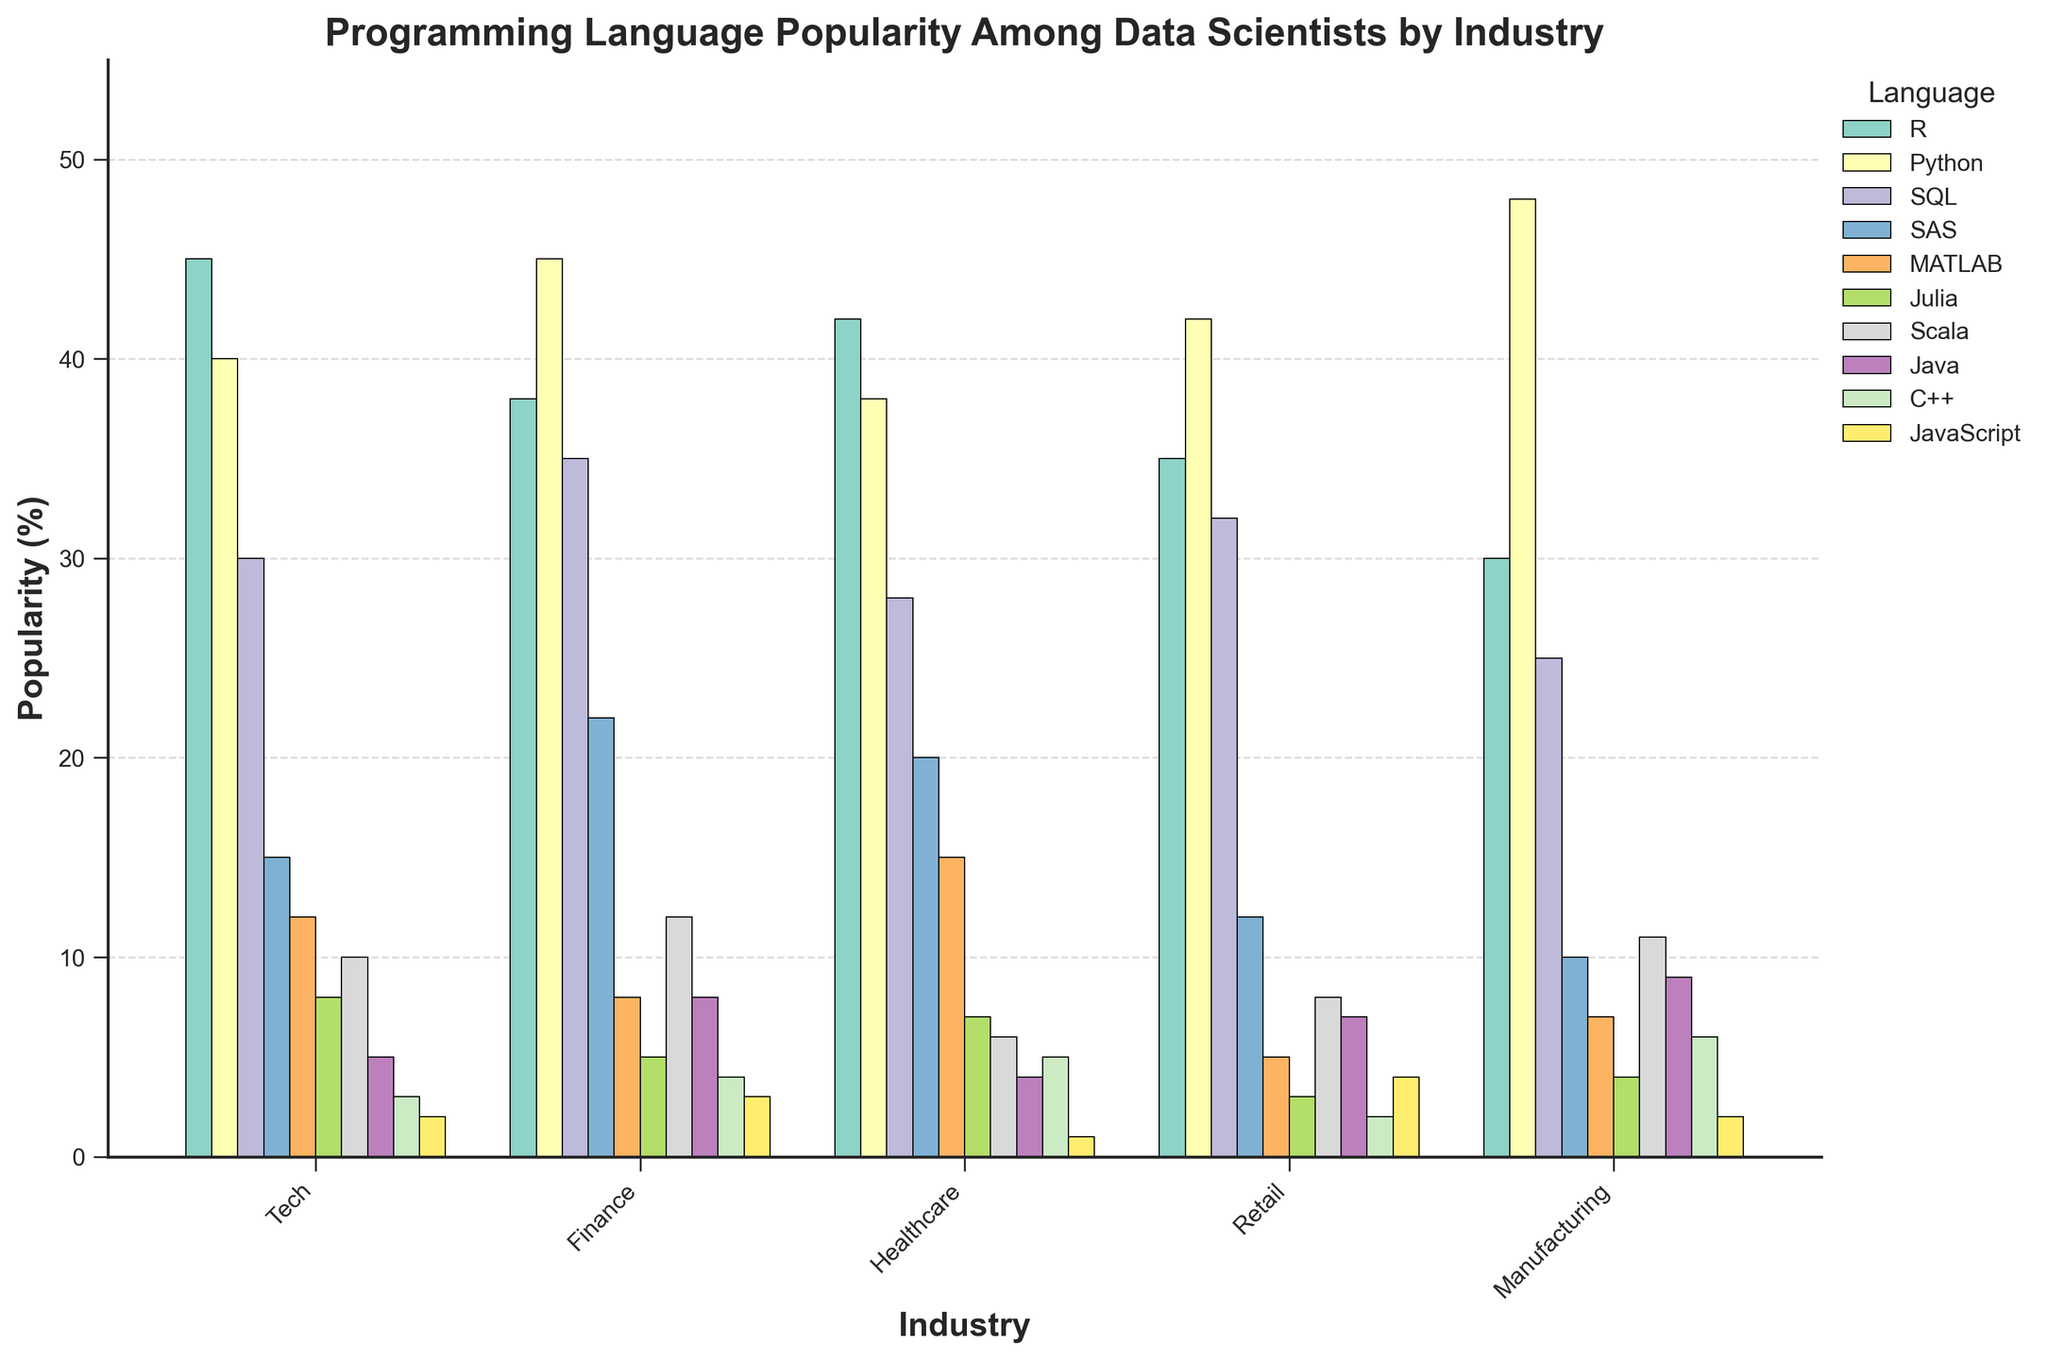What's the most popular programming language in the Tech industry? Examine the heights of the bars corresponding to the Tech industry. The highest bar belongs to R with a value of 45%.
Answer: R What's the cumulative popularity of Python in Finance and Healthcare industries? Identify the bars representing Python for both Finance and Healthcare industries and sum their values: 45% (Finance) + 38% (Healthcare) = 83%.
Answer: 83% Which language shows the most consistent popularity across all industries? For each language, examine the variation in bar heights across industries. Python shows relatively high consistency with values ranging from 38% to 48%.
Answer: Python Is R more popular in Retail or Manufacturing? Compare the bar heights for R between Retail (35%) and Manufacturing (30%). R is more popular in Retail.
Answer: Retail Which industry shows the least interest in JavaScript? Look at the bar heights for JavaScript across all industries and find the smallest value. JavaScript has the least popularity in Healthcare with a bar height of 1%.
Answer: Healthcare What's the difference in popularity between R and Python in Manufacturing? Find the bar heights for R (30%) and Python (48%) in Manufacturing and calculate the difference: 48% - 30% = 18%.
Answer: 18% Among SQL, SAS, and MATLAB, which language is most popular in the Healthcare industry? Compare the bar heights of SQL (28%), SAS (20%), and MATLAB (15%) in the Healthcare industry. SQL is the most popular among the three.
Answer: SQL Is SQL more popular in Finance or Manufacturing? By how much? Compare the bar heights for SQL in Finance (35%) and Manufacturing (25%) and calculate the difference: 35% - 25% = 10%.
Answer: Finance, 10% What's the average popularity of R across all industries? Sum the values of R for all industries and divide by the number of industries: (45% + 38% + 42% + 35% + 30%) / 5 = 38%.
Answer: 38% Which language has the highest popularity difference between Tech and Retail industries? Compare the differences in bar heights between Tech and Retail for each language. Python shows the highest difference with Tech (40%) and Retail (42%) giving a difference of 2%.
Answer: Python 